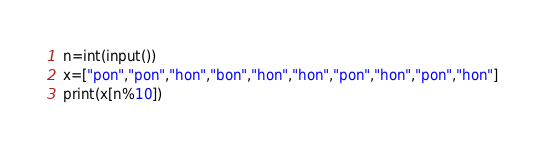Convert code to text. <code><loc_0><loc_0><loc_500><loc_500><_Python_>n=int(input())
x=["pon","pon","hon","bon","hon","hon","pon","hon","pon","hon"]
print(x[n%10])
</code> 